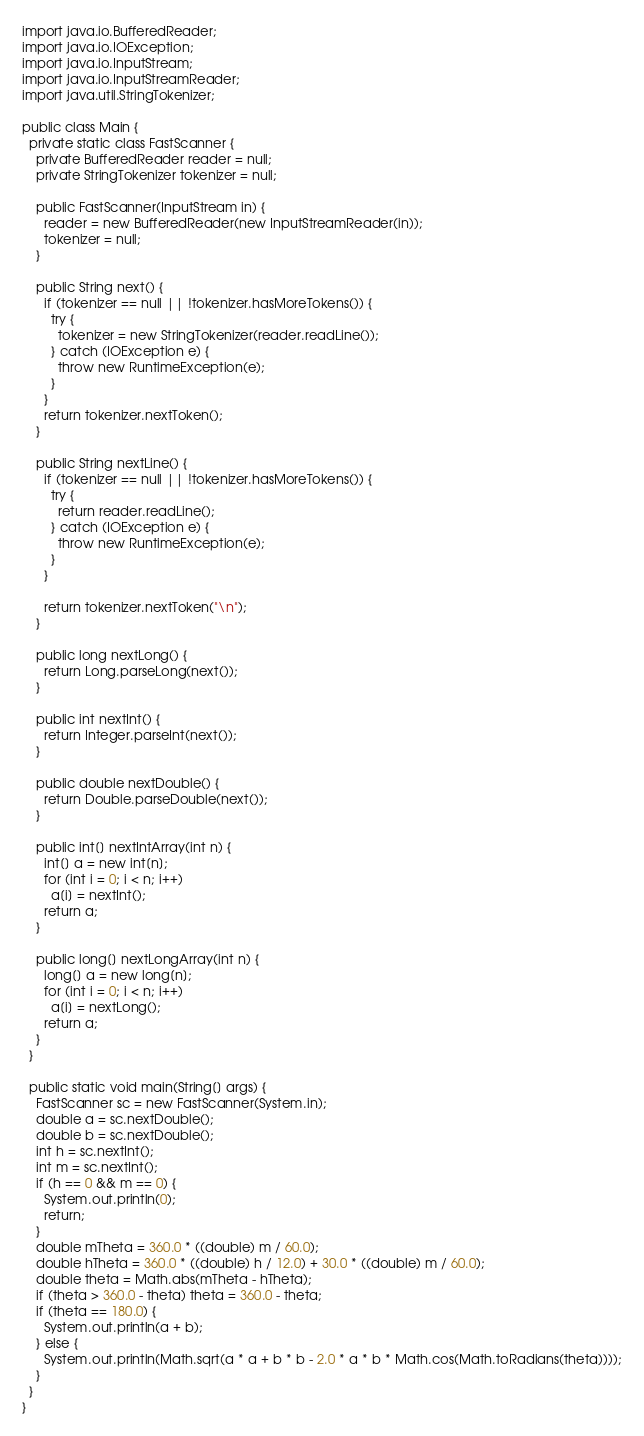Convert code to text. <code><loc_0><loc_0><loc_500><loc_500><_Java_>import java.io.BufferedReader;
import java.io.IOException;
import java.io.InputStream;
import java.io.InputStreamReader;
import java.util.StringTokenizer;

public class Main {
  private static class FastScanner {
    private BufferedReader reader = null;
    private StringTokenizer tokenizer = null;

    public FastScanner(InputStream in) {
      reader = new BufferedReader(new InputStreamReader(in));
      tokenizer = null;
    }

    public String next() {
      if (tokenizer == null || !tokenizer.hasMoreTokens()) {
        try {
          tokenizer = new StringTokenizer(reader.readLine());
        } catch (IOException e) {
          throw new RuntimeException(e);
        }
      }
      return tokenizer.nextToken();
    }

    public String nextLine() {
      if (tokenizer == null || !tokenizer.hasMoreTokens()) {
        try {
          return reader.readLine();
        } catch (IOException e) {
          throw new RuntimeException(e);
        }
      }

      return tokenizer.nextToken("\n");
    }

    public long nextLong() {
      return Long.parseLong(next());
    }

    public int nextInt() {
      return Integer.parseInt(next());
    }

    public double nextDouble() {
      return Double.parseDouble(next());
    }

    public int[] nextIntArray(int n) {
      int[] a = new int[n];
      for (int i = 0; i < n; i++)
        a[i] = nextInt();
      return a;
    }

    public long[] nextLongArray(int n) {
      long[] a = new long[n];
      for (int i = 0; i < n; i++)
        a[i] = nextLong();
      return a;
    }
  }

  public static void main(String[] args) {
    FastScanner sc = new FastScanner(System.in);
    double a = sc.nextDouble();
    double b = sc.nextDouble();
    int h = sc.nextInt();
    int m = sc.nextInt();
    if (h == 0 && m == 0) {
      System.out.println(0);
      return;
    }
    double mTheta = 360.0 * ((double) m / 60.0);
    double hTheta = 360.0 * ((double) h / 12.0) + 30.0 * ((double) m / 60.0);
    double theta = Math.abs(mTheta - hTheta);
    if (theta > 360.0 - theta) theta = 360.0 - theta;
    if (theta == 180.0) {
      System.out.println(a + b);
    } else {
      System.out.println(Math.sqrt(a * a + b * b - 2.0 * a * b * Math.cos(Math.toRadians(theta))));
    }
  }
}</code> 